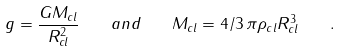<formula> <loc_0><loc_0><loc_500><loc_500>g = \frac { G M _ { c l } } { R ^ { 2 } _ { c l } } \quad a n d \quad M _ { c l } = 4 / 3 \, \pi \rho _ { c l } R ^ { 3 } _ { c l } \quad .</formula> 